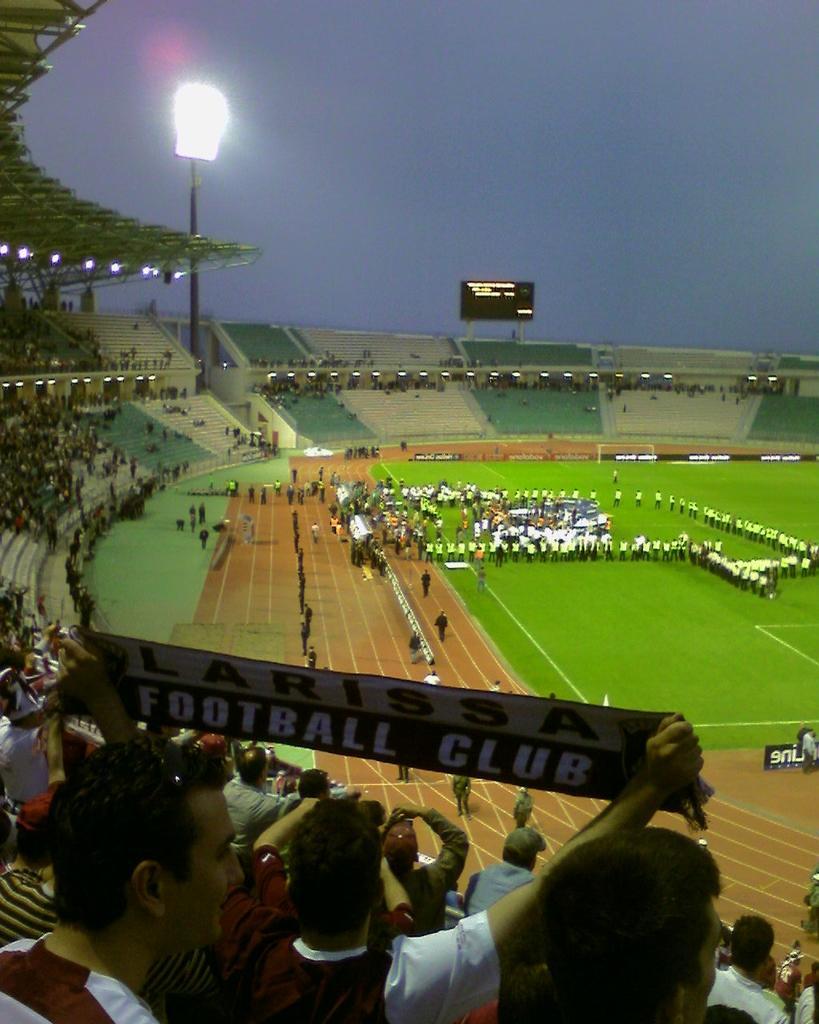Could you give a brief overview of what you see in this image? In the foreground I can see boards, lights and a crowd in the stadium. In the middle I can see a group of people are standing on the ground, fence and so on. At the top I can see the blue sky. This image is taken may be during night. 